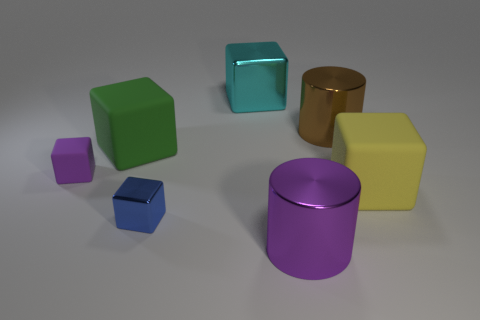Can you tell me the material the objects might be made of, based on their appearance? The objects seem to have a smooth texture and reflective surface, suggestive of materials like polished plastic or metal, each giving a different impression through its finishing and reflection traits. Is there anything in the image that suggests these objects could be used in a specific setting? The uniform and clean appearance of the objects, coupled with their differing sizes and shapes, suggests that they could be used for educational purposes, like demonstrating geometry, or as part of a modern decor setting for their aesthetic value. 